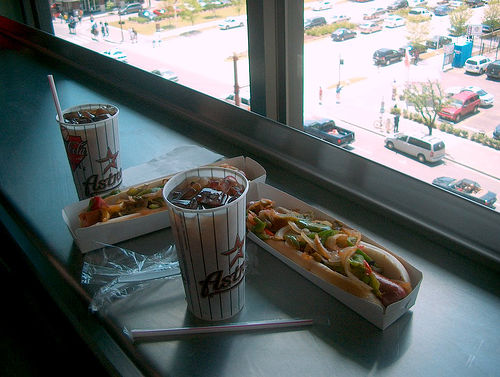Extract all visible text content from this image. Astro Astr 